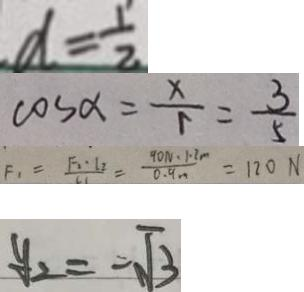Convert formula to latex. <formula><loc_0><loc_0><loc_500><loc_500>d = \frac { 1 } { 2 } 
 \cos \alpha = \frac { x } { r } = \frac { 3 } { 5 } 
 F _ { 1 } = \frac { F _ { 2 } \cdot l _ { 2 } } { l _ { 1 } } = \frac { 9 0 N \cdot 1 . 2 m } { 0 . 9 m } = 1 2 0 N 
 y _ { 2 } = - \sqrt { 3 }</formula> 